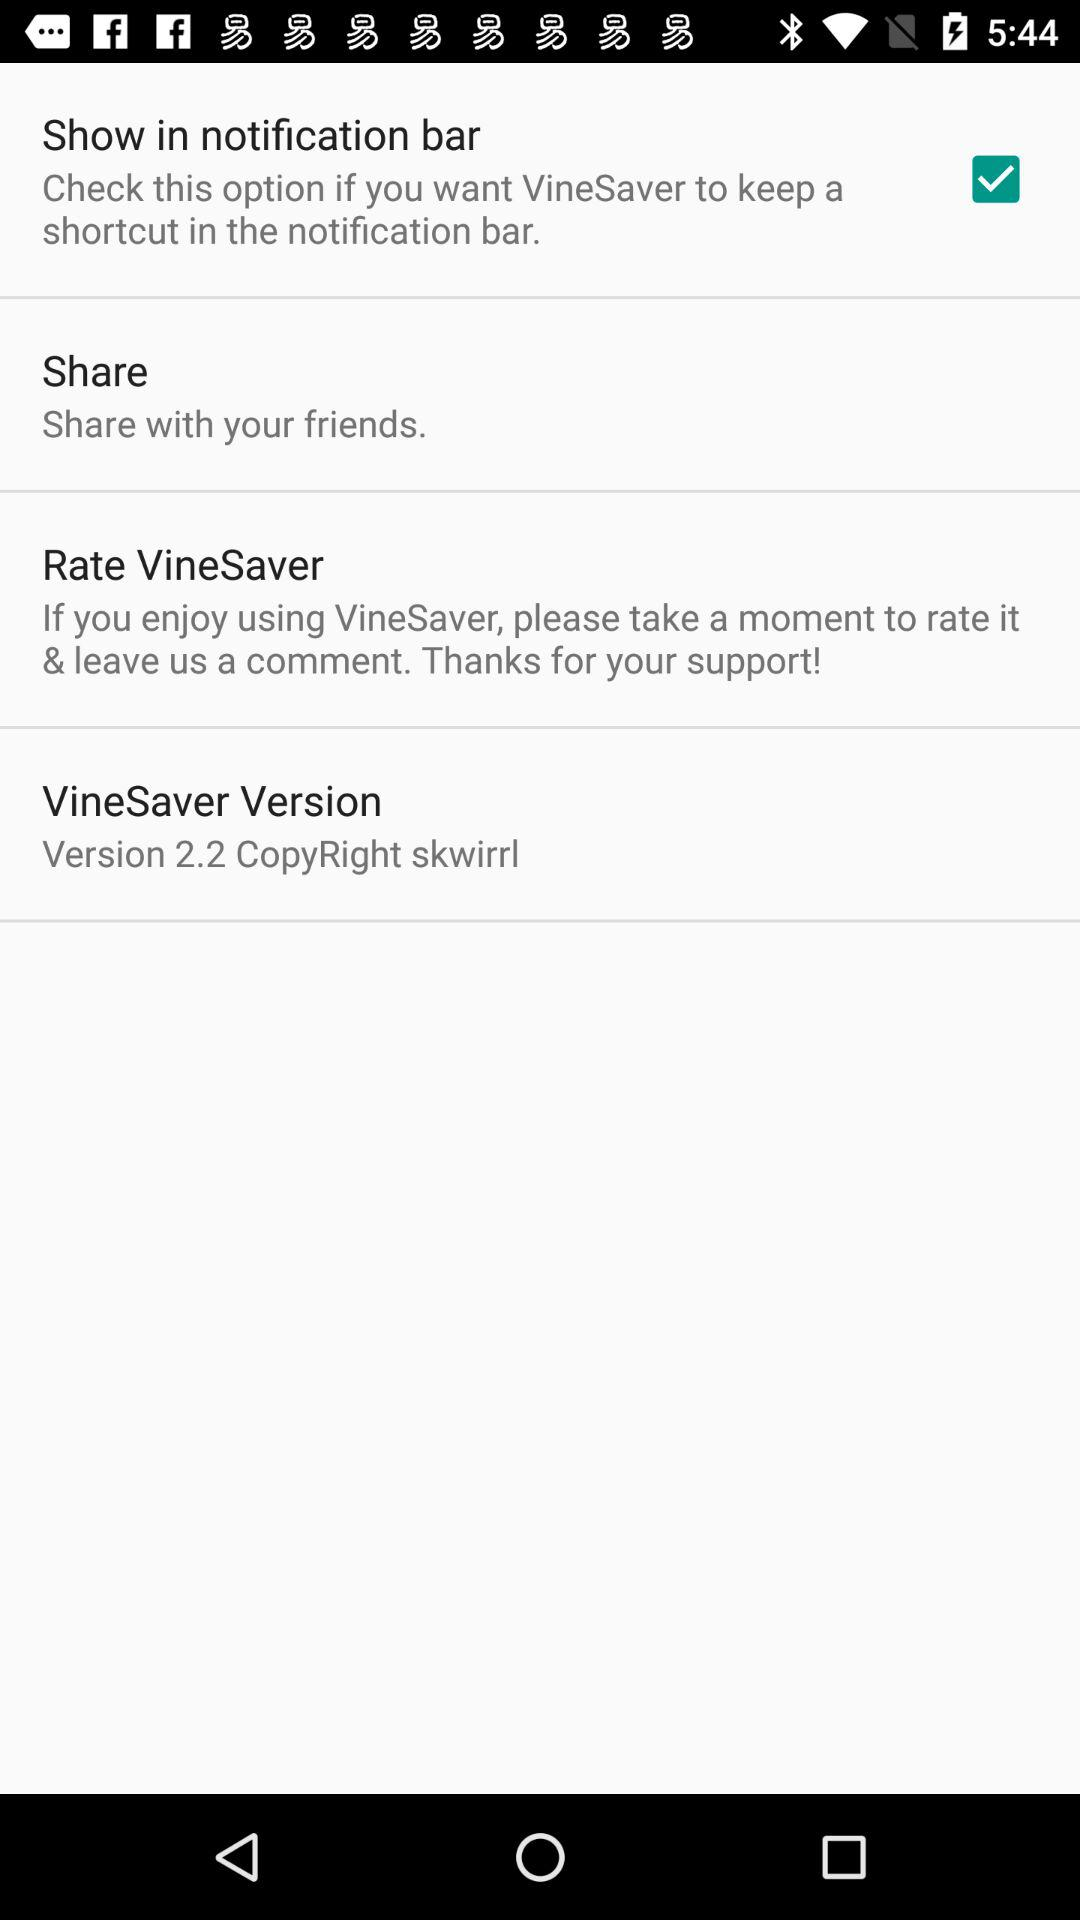What is the status of "Show in notification bar"? The status is "on". 